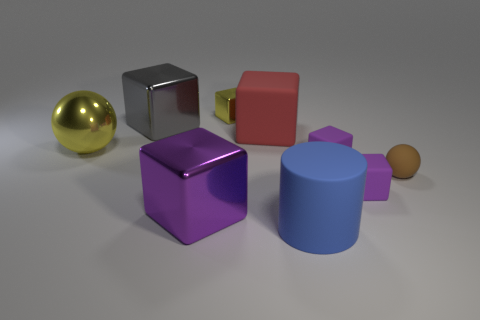What number of other objects are the same color as the cylinder?
Your answer should be compact. 0. Do the sphere on the left side of the tiny sphere and the small shiny block have the same color?
Give a very brief answer. Yes. What number of yellow objects are tiny blocks or big matte cubes?
Offer a terse response. 1. Does the yellow thing right of the large purple metal cube have the same material as the small brown thing?
Offer a very short reply. No. How many objects are either blue metallic balls or small objects that are in front of the brown ball?
Your answer should be very brief. 1. What number of red objects are right of the yellow object in front of the yellow thing behind the large gray block?
Keep it short and to the point. 1. Is the shape of the purple rubber object that is in front of the brown matte sphere the same as  the red rubber object?
Ensure brevity in your answer.  Yes. Is there a small purple thing behind the large rubber thing in front of the brown rubber sphere?
Provide a succinct answer. Yes. How many big matte things are there?
Ensure brevity in your answer.  2. There is a block that is on the right side of the yellow block and in front of the small rubber sphere; what is its color?
Offer a terse response. Purple. 